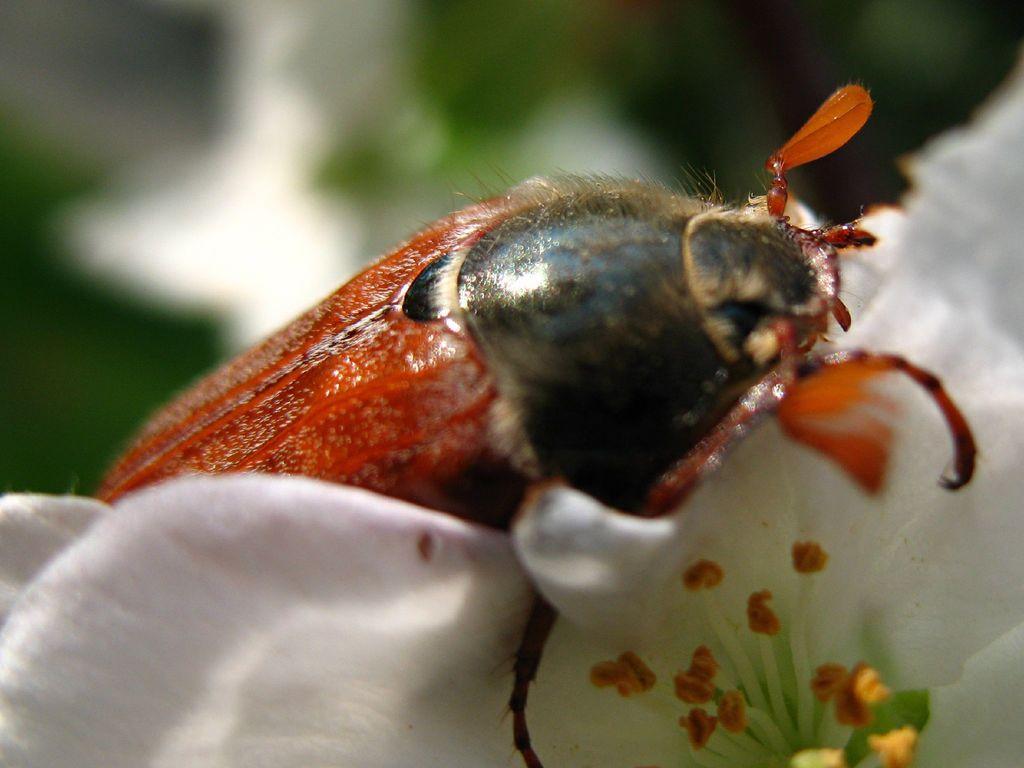How would you summarize this image in a sentence or two? In this image I can see a white colour flower in the front and on it I can see an insect. I can see colour of the insect is orange and black. I can see this image is little bit blurry in the background. 